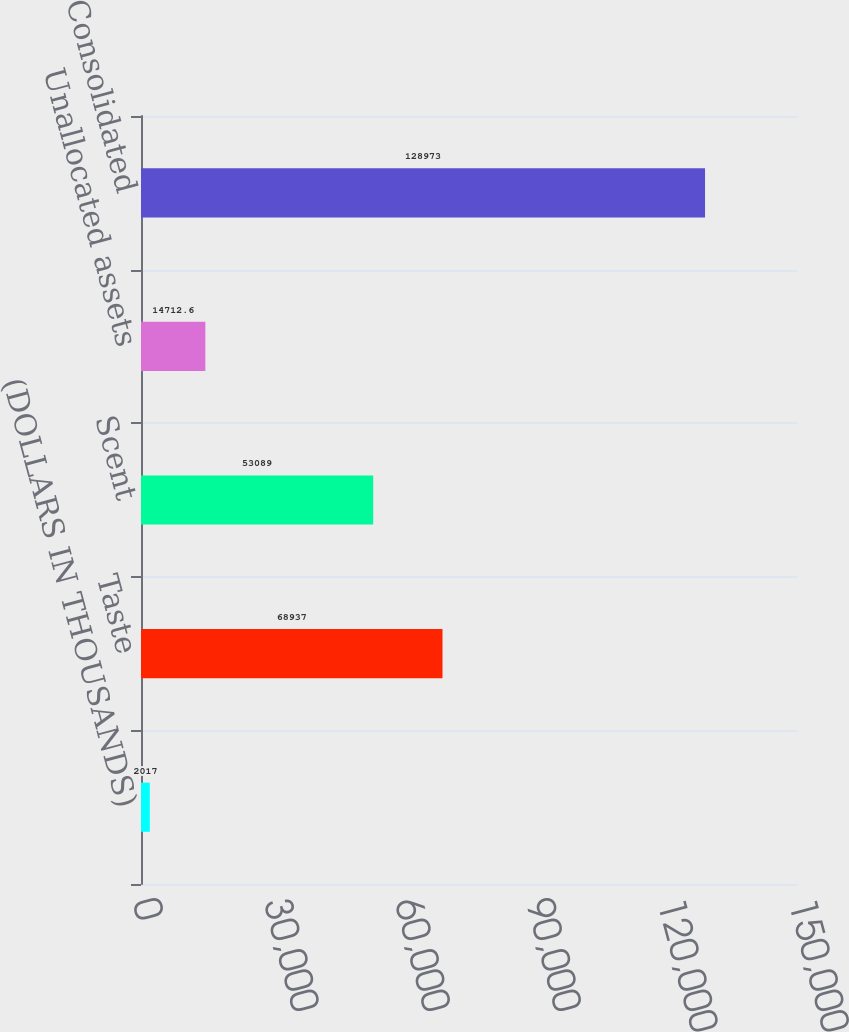Convert chart. <chart><loc_0><loc_0><loc_500><loc_500><bar_chart><fcel>(DOLLARS IN THOUSANDS)<fcel>Taste<fcel>Scent<fcel>Unallocated assets<fcel>Consolidated<nl><fcel>2017<fcel>68937<fcel>53089<fcel>14712.6<fcel>128973<nl></chart> 